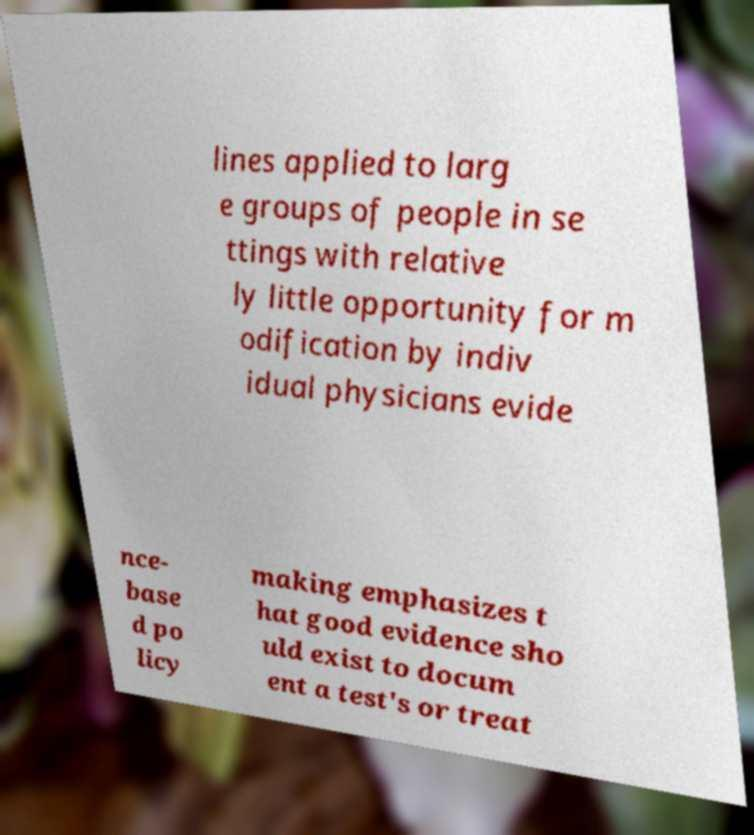Please identify and transcribe the text found in this image. lines applied to larg e groups of people in se ttings with relative ly little opportunity for m odification by indiv idual physicians evide nce- base d po licy making emphasizes t hat good evidence sho uld exist to docum ent a test's or treat 